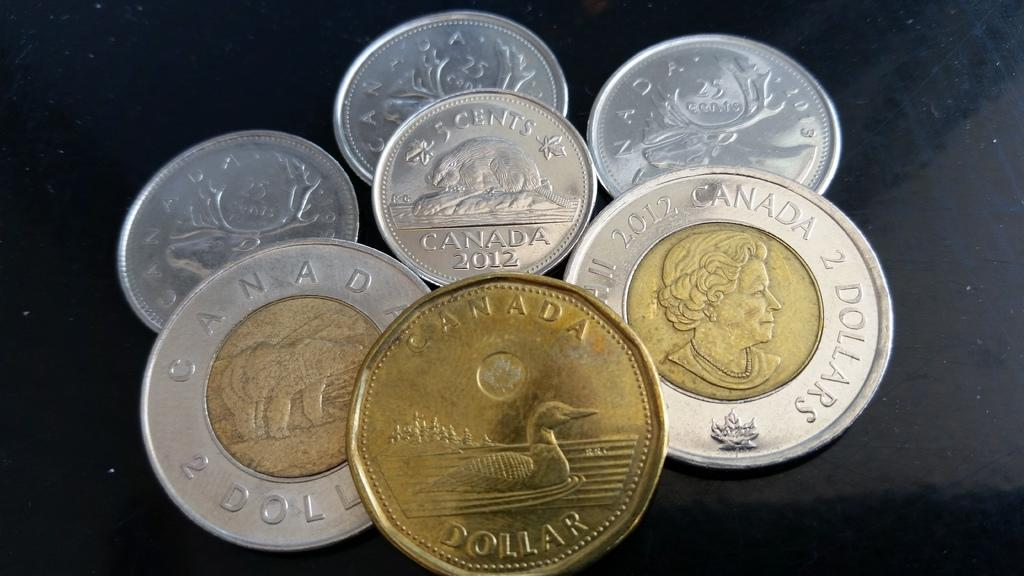<image>
Provide a brief description of the given image. A collection of Canadian coins includes a dollar with a duck on it. 